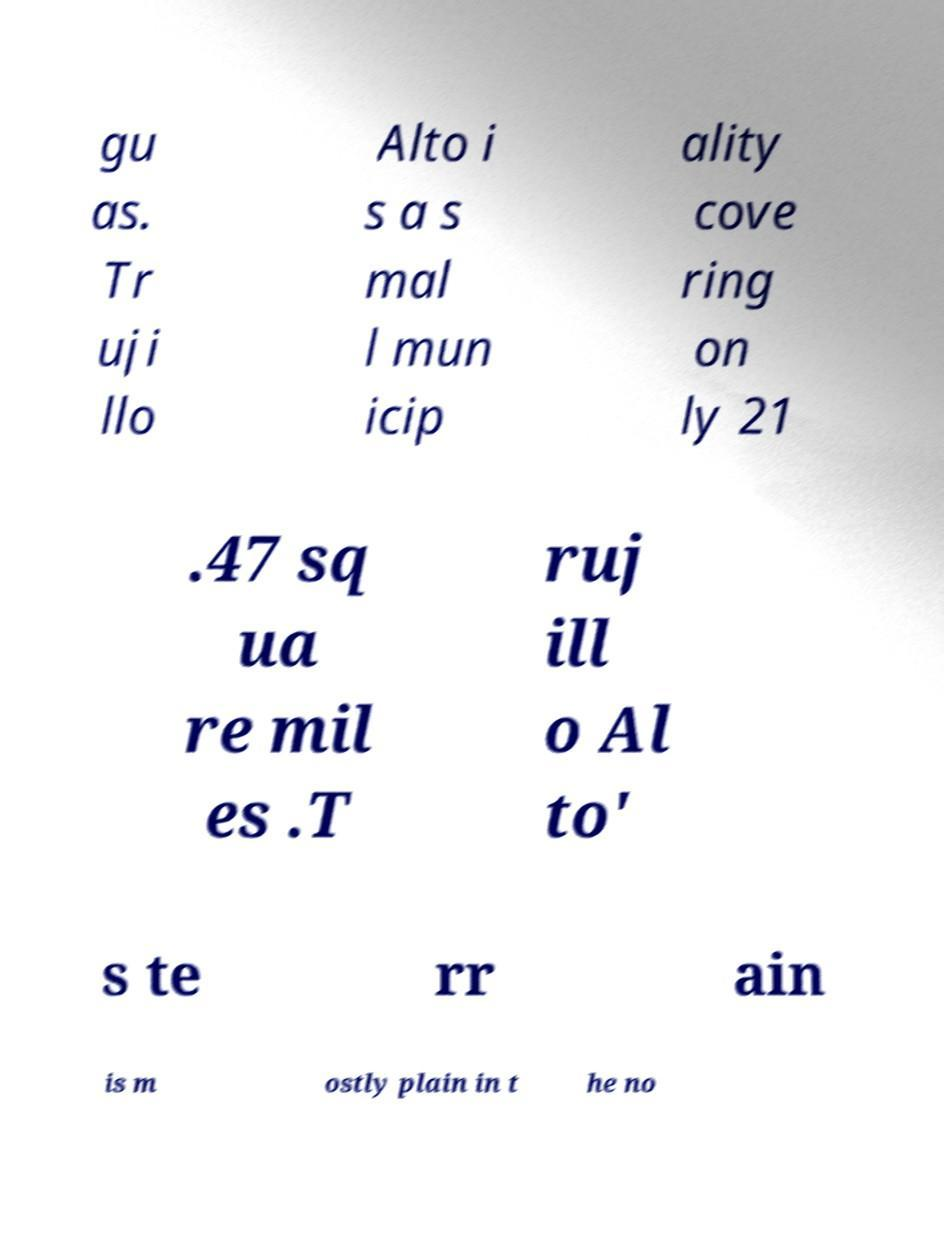Please identify and transcribe the text found in this image. gu as. Tr uji llo Alto i s a s mal l mun icip ality cove ring on ly 21 .47 sq ua re mil es .T ruj ill o Al to' s te rr ain is m ostly plain in t he no 